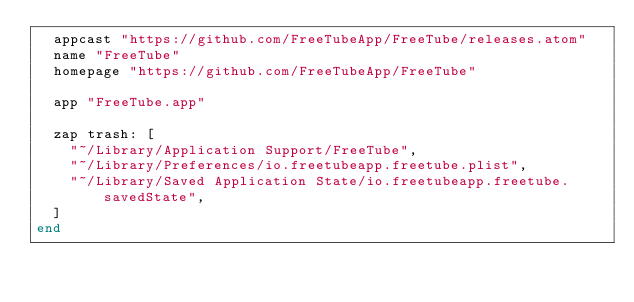Convert code to text. <code><loc_0><loc_0><loc_500><loc_500><_Ruby_>  appcast "https://github.com/FreeTubeApp/FreeTube/releases.atom"
  name "FreeTube"
  homepage "https://github.com/FreeTubeApp/FreeTube"

  app "FreeTube.app"

  zap trash: [
    "~/Library/Application Support/FreeTube",
    "~/Library/Preferences/io.freetubeapp.freetube.plist",
    "~/Library/Saved Application State/io.freetubeapp.freetube.savedState",
  ]
end
</code> 